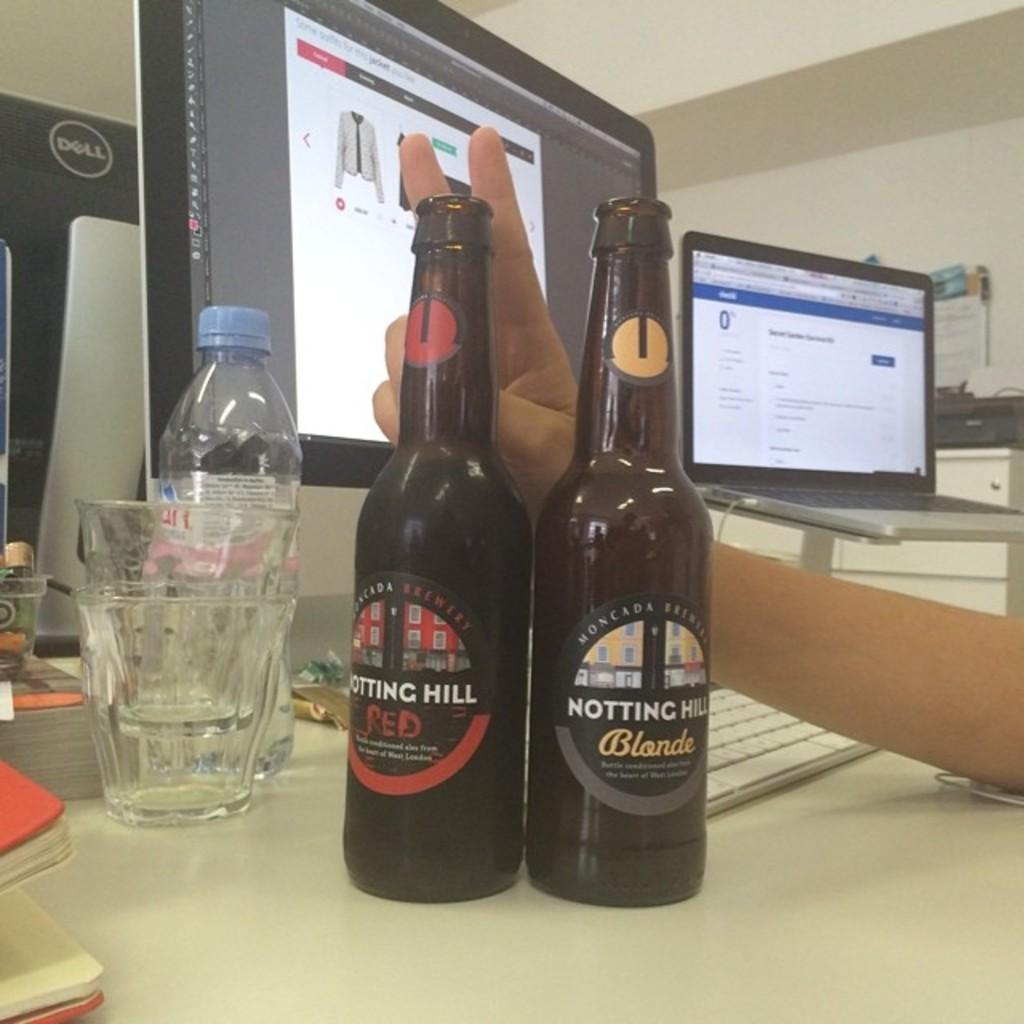<image>
Create a compact narrative representing the image presented. A bottle of Notting Hill Blonde sits next to a bottle of red. 